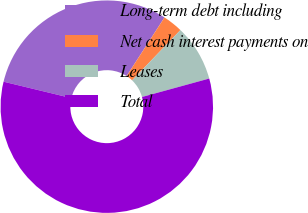Convert chart to OTSL. <chart><loc_0><loc_0><loc_500><loc_500><pie_chart><fcel>Long-term debt including<fcel>Net cash interest payments on<fcel>Leases<fcel>Total<nl><fcel>30.36%<fcel>3.05%<fcel>8.55%<fcel>58.04%<nl></chart> 